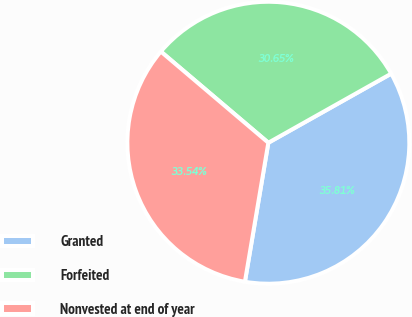Convert chart to OTSL. <chart><loc_0><loc_0><loc_500><loc_500><pie_chart><fcel>Granted<fcel>Forfeited<fcel>Nonvested at end of year<nl><fcel>35.81%<fcel>30.65%<fcel>33.54%<nl></chart> 